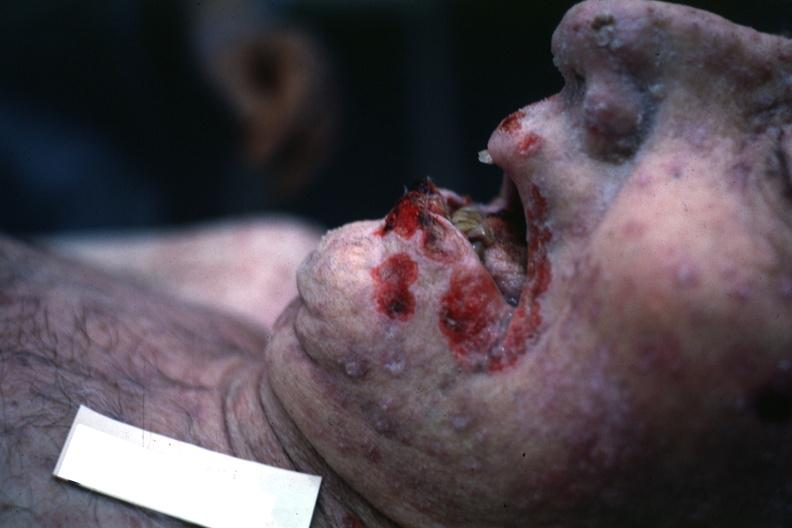what does this image show?
Answer the question using a single word or phrase. Good but grotesque 